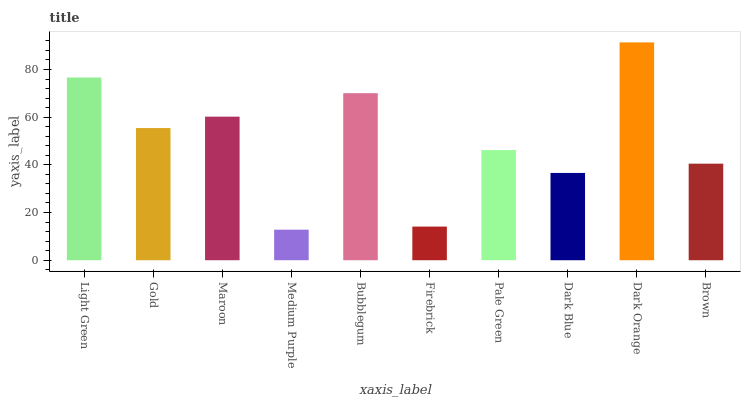Is Gold the minimum?
Answer yes or no. No. Is Gold the maximum?
Answer yes or no. No. Is Light Green greater than Gold?
Answer yes or no. Yes. Is Gold less than Light Green?
Answer yes or no. Yes. Is Gold greater than Light Green?
Answer yes or no. No. Is Light Green less than Gold?
Answer yes or no. No. Is Gold the high median?
Answer yes or no. Yes. Is Pale Green the low median?
Answer yes or no. Yes. Is Maroon the high median?
Answer yes or no. No. Is Dark Orange the low median?
Answer yes or no. No. 